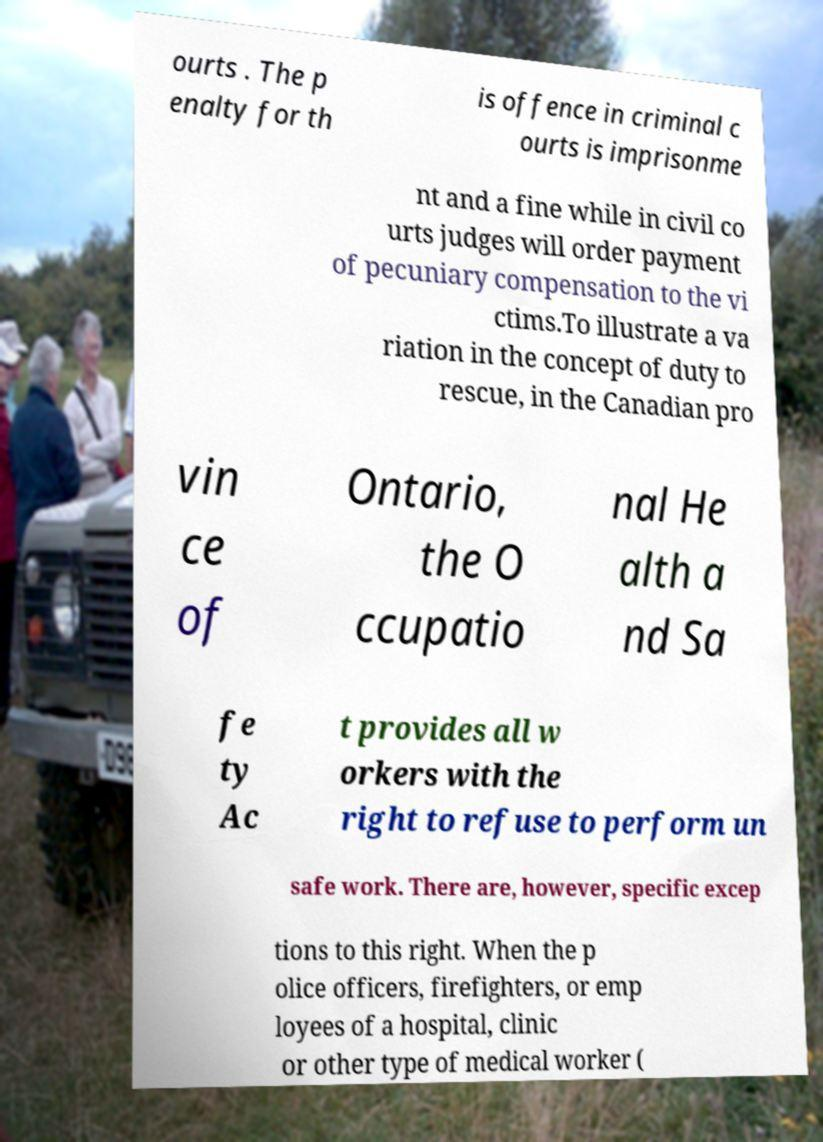Please identify and transcribe the text found in this image. ourts . The p enalty for th is offence in criminal c ourts is imprisonme nt and a fine while in civil co urts judges will order payment of pecuniary compensation to the vi ctims.To illustrate a va riation in the concept of duty to rescue, in the Canadian pro vin ce of Ontario, the O ccupatio nal He alth a nd Sa fe ty Ac t provides all w orkers with the right to refuse to perform un safe work. There are, however, specific excep tions to this right. When the p olice officers, firefighters, or emp loyees of a hospital, clinic or other type of medical worker ( 